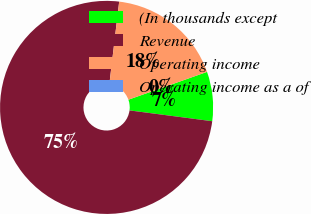<chart> <loc_0><loc_0><loc_500><loc_500><pie_chart><fcel>(In thousands except<fcel>Revenue<fcel>Operating income<fcel>Operating income as a of<nl><fcel>7.48%<fcel>74.81%<fcel>17.7%<fcel>0.0%<nl></chart> 